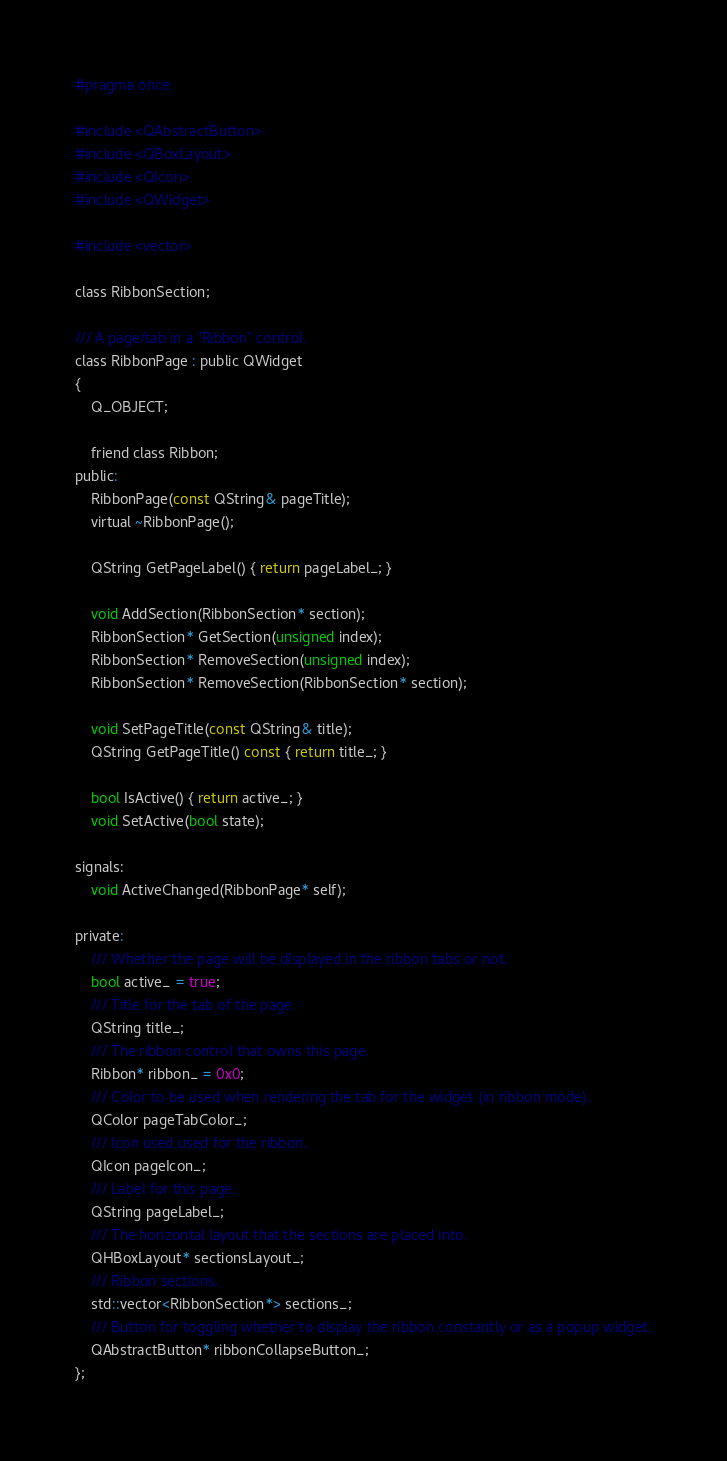Convert code to text. <code><loc_0><loc_0><loc_500><loc_500><_C_>#pragma once

#include <QAbstractButton>
#include <QBoxLayout>
#include <QIcon>
#include <QWidget>

#include <vector>

class RibbonSection;

/// A page/tab in a "Ribbon" control.
class RibbonPage : public QWidget
{
    Q_OBJECT;

    friend class Ribbon;
public:
    RibbonPage(const QString& pageTitle);
    virtual ~RibbonPage();

    QString GetPageLabel() { return pageLabel_; }

    void AddSection(RibbonSection* section);
    RibbonSection* GetSection(unsigned index);
    RibbonSection* RemoveSection(unsigned index);
    RibbonSection* RemoveSection(RibbonSection* section);

    void SetPageTitle(const QString& title);
    QString GetPageTitle() const { return title_; }

    bool IsActive() { return active_; }
    void SetActive(bool state);

signals:
    void ActiveChanged(RibbonPage* self);

private:
    /// Whether the page will be displayed in the ribbon tabs or not.
    bool active_ = true;
    /// Title for the tab of the page.
    QString title_;
    /// The ribbon control that owns this page.
    Ribbon* ribbon_ = 0x0;
    /// Color to be used when rendering the tab for the widget (in ribbon mode).
    QColor pageTabColor_;
    /// Icon used used for the ribbon.
    QIcon pageIcon_;
    /// Label for this page.
    QString pageLabel_;
    /// The horizontal layout that the sections are placed into.
    QHBoxLayout* sectionsLayout_;
    /// Ribbon sections.
    std::vector<RibbonSection*> sections_;
    /// Button for toggling whether to display the ribbon constantly or as a popup widget.
    QAbstractButton* ribbonCollapseButton_;
};</code> 